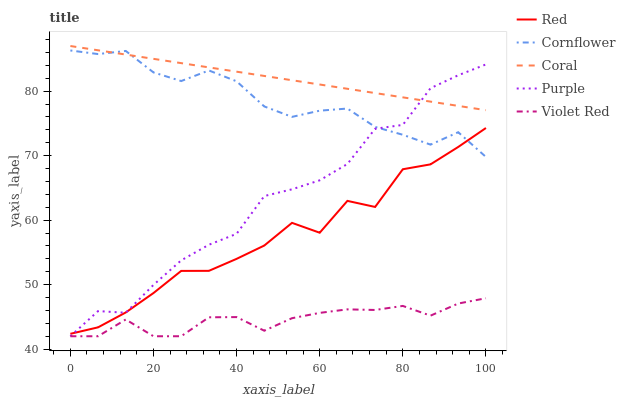Does Violet Red have the minimum area under the curve?
Answer yes or no. Yes. Does Coral have the maximum area under the curve?
Answer yes or no. Yes. Does Cornflower have the minimum area under the curve?
Answer yes or no. No. Does Cornflower have the maximum area under the curve?
Answer yes or no. No. Is Coral the smoothest?
Answer yes or no. Yes. Is Red the roughest?
Answer yes or no. Yes. Is Cornflower the smoothest?
Answer yes or no. No. Is Cornflower the roughest?
Answer yes or no. No. Does Purple have the lowest value?
Answer yes or no. Yes. Does Cornflower have the lowest value?
Answer yes or no. No. Does Coral have the highest value?
Answer yes or no. Yes. Does Cornflower have the highest value?
Answer yes or no. No. Is Violet Red less than Red?
Answer yes or no. Yes. Is Coral greater than Red?
Answer yes or no. Yes. Does Purple intersect Red?
Answer yes or no. Yes. Is Purple less than Red?
Answer yes or no. No. Is Purple greater than Red?
Answer yes or no. No. Does Violet Red intersect Red?
Answer yes or no. No. 